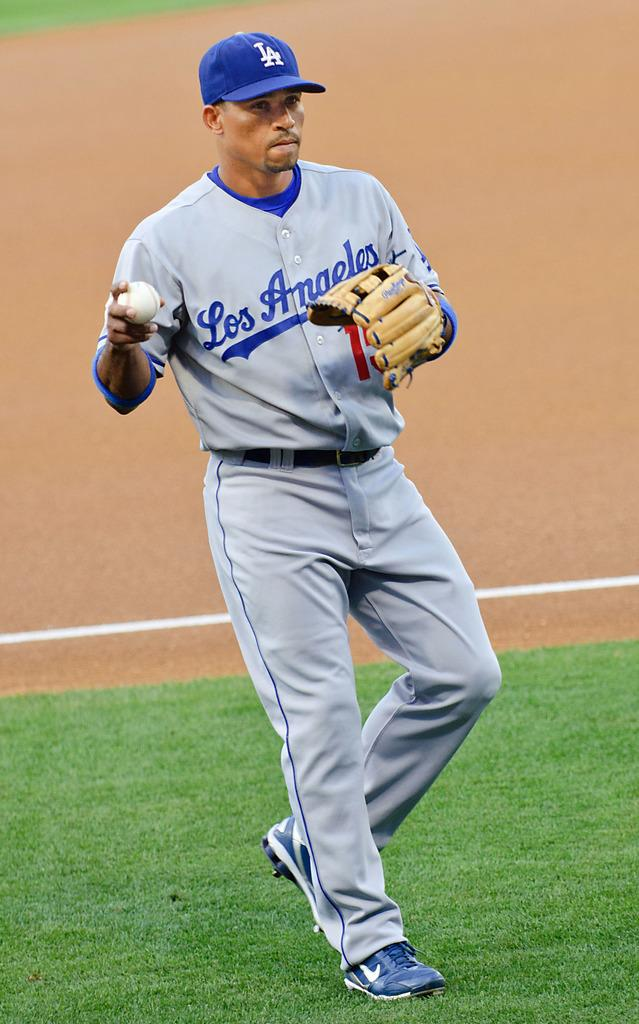<image>
Write a terse but informative summary of the picture. Baseball player for Los Angeles getting ready to throw the ball. 